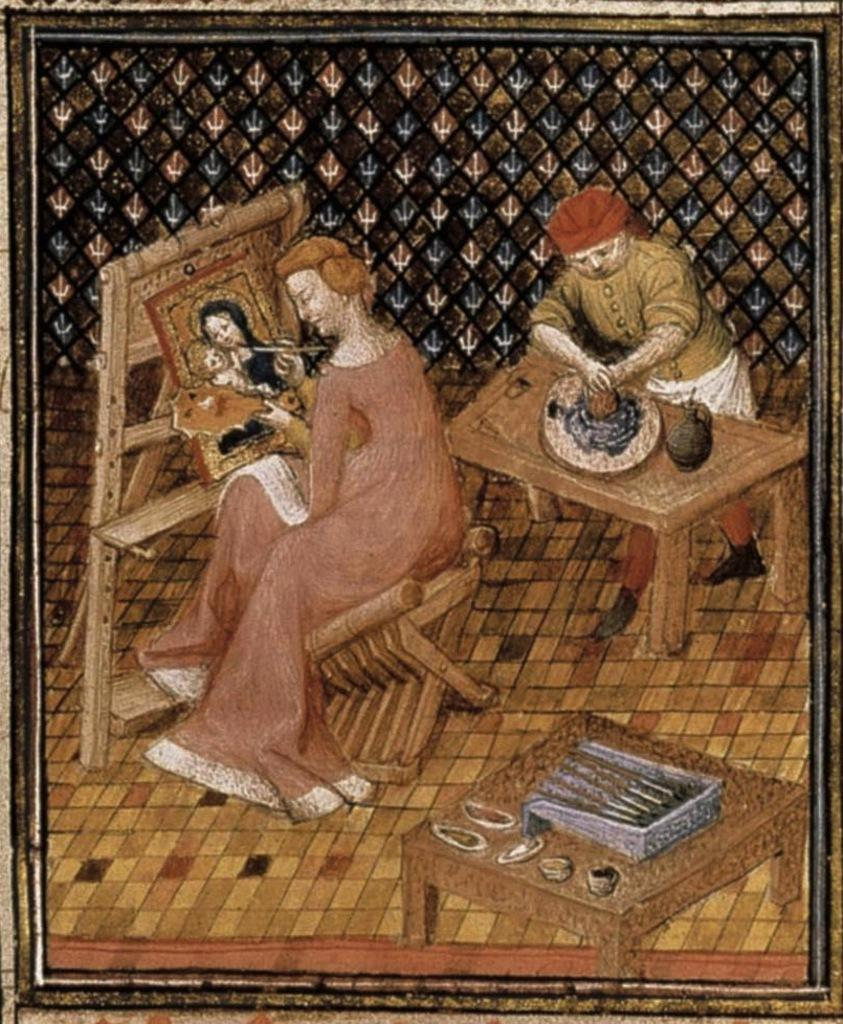What is depicted in the image? There is a painting in the image. What subjects are included in the painting? The painting contains people, tables, and other objects. What type of yarn is being used by the people in the painting? There is no yarn present in the painting; it only contains people, tables, and other objects. What time of day is depicted in the painting? The time of day is not specified in the painting; it only contains people, tables, and other objects. 